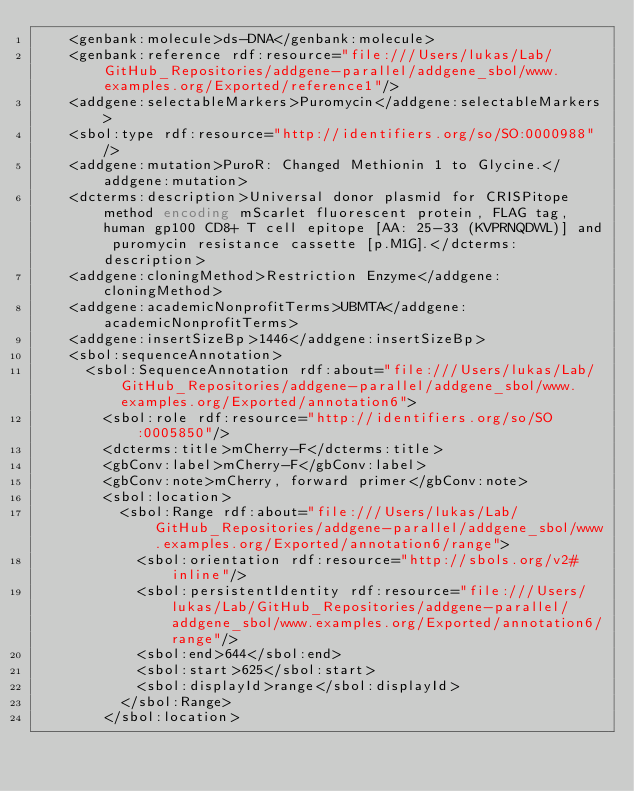<code> <loc_0><loc_0><loc_500><loc_500><_XML_>    <genbank:molecule>ds-DNA</genbank:molecule>
    <genbank:reference rdf:resource="file:///Users/lukas/Lab/GitHub_Repositories/addgene-parallel/addgene_sbol/www.examples.org/Exported/reference1"/>
    <addgene:selectableMarkers>Puromycin</addgene:selectableMarkers>
    <sbol:type rdf:resource="http://identifiers.org/so/SO:0000988"/>
    <addgene:mutation>PuroR: Changed Methionin 1 to Glycine.</addgene:mutation>
    <dcterms:description>Universal donor plasmid for CRISPitope method encoding mScarlet fluorescent protein, FLAG tag, human gp100 CD8+ T cell epitope [AA: 25-33 (KVPRNQDWL)] and puromycin resistance cassette [p.M1G].</dcterms:description>
    <addgene:cloningMethod>Restriction Enzyme</addgene:cloningMethod>
    <addgene:academicNonprofitTerms>UBMTA</addgene:academicNonprofitTerms>
    <addgene:insertSizeBp>1446</addgene:insertSizeBp>
    <sbol:sequenceAnnotation>
      <sbol:SequenceAnnotation rdf:about="file:///Users/lukas/Lab/GitHub_Repositories/addgene-parallel/addgene_sbol/www.examples.org/Exported/annotation6">
        <sbol:role rdf:resource="http://identifiers.org/so/SO:0005850"/>
        <dcterms:title>mCherry-F</dcterms:title>
        <gbConv:label>mCherry-F</gbConv:label>
        <gbConv:note>mCherry, forward primer</gbConv:note>
        <sbol:location>
          <sbol:Range rdf:about="file:///Users/lukas/Lab/GitHub_Repositories/addgene-parallel/addgene_sbol/www.examples.org/Exported/annotation6/range">
            <sbol:orientation rdf:resource="http://sbols.org/v2#inline"/>
            <sbol:persistentIdentity rdf:resource="file:///Users/lukas/Lab/GitHub_Repositories/addgene-parallel/addgene_sbol/www.examples.org/Exported/annotation6/range"/>
            <sbol:end>644</sbol:end>
            <sbol:start>625</sbol:start>
            <sbol:displayId>range</sbol:displayId>
          </sbol:Range>
        </sbol:location></code> 